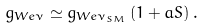Convert formula to latex. <formula><loc_0><loc_0><loc_500><loc_500>g _ { W e \nu } \simeq g _ { W e \nu _ { S M } } \left ( 1 + a S \right ) .</formula> 